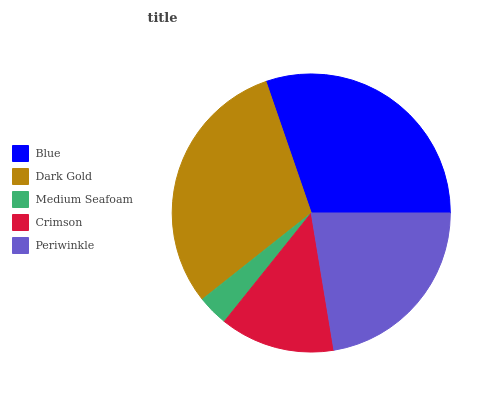Is Medium Seafoam the minimum?
Answer yes or no. Yes. Is Dark Gold the maximum?
Answer yes or no. Yes. Is Dark Gold the minimum?
Answer yes or no. No. Is Medium Seafoam the maximum?
Answer yes or no. No. Is Dark Gold greater than Medium Seafoam?
Answer yes or no. Yes. Is Medium Seafoam less than Dark Gold?
Answer yes or no. Yes. Is Medium Seafoam greater than Dark Gold?
Answer yes or no. No. Is Dark Gold less than Medium Seafoam?
Answer yes or no. No. Is Periwinkle the high median?
Answer yes or no. Yes. Is Periwinkle the low median?
Answer yes or no. Yes. Is Dark Gold the high median?
Answer yes or no. No. Is Crimson the low median?
Answer yes or no. No. 